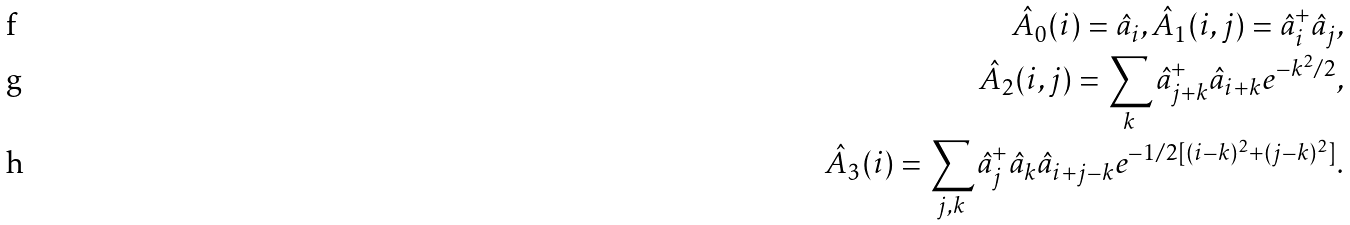Convert formula to latex. <formula><loc_0><loc_0><loc_500><loc_500>\hat { A } _ { 0 } ( i ) = \hat { a } _ { i } , \hat { A } _ { 1 } ( i , j ) = \hat { a } _ { i } ^ { + } \hat { a } _ { j } , \\ \hat { A } _ { 2 } ( i , j ) = \sum _ { k } { \hat { a } _ { j + k } ^ { + } \hat { a } _ { i + k } e ^ { - k ^ { 2 } / 2 } } , \\ \hat { A } _ { 3 } ( i ) = \sum _ { j , k } \hat { a } _ { j } ^ { + } \hat { a } _ { k } \hat { a } _ { i + j - k } e ^ { - 1 / 2 [ ( i - k ) ^ { 2 } + ( j - k ) ^ { 2 } ] } .</formula> 